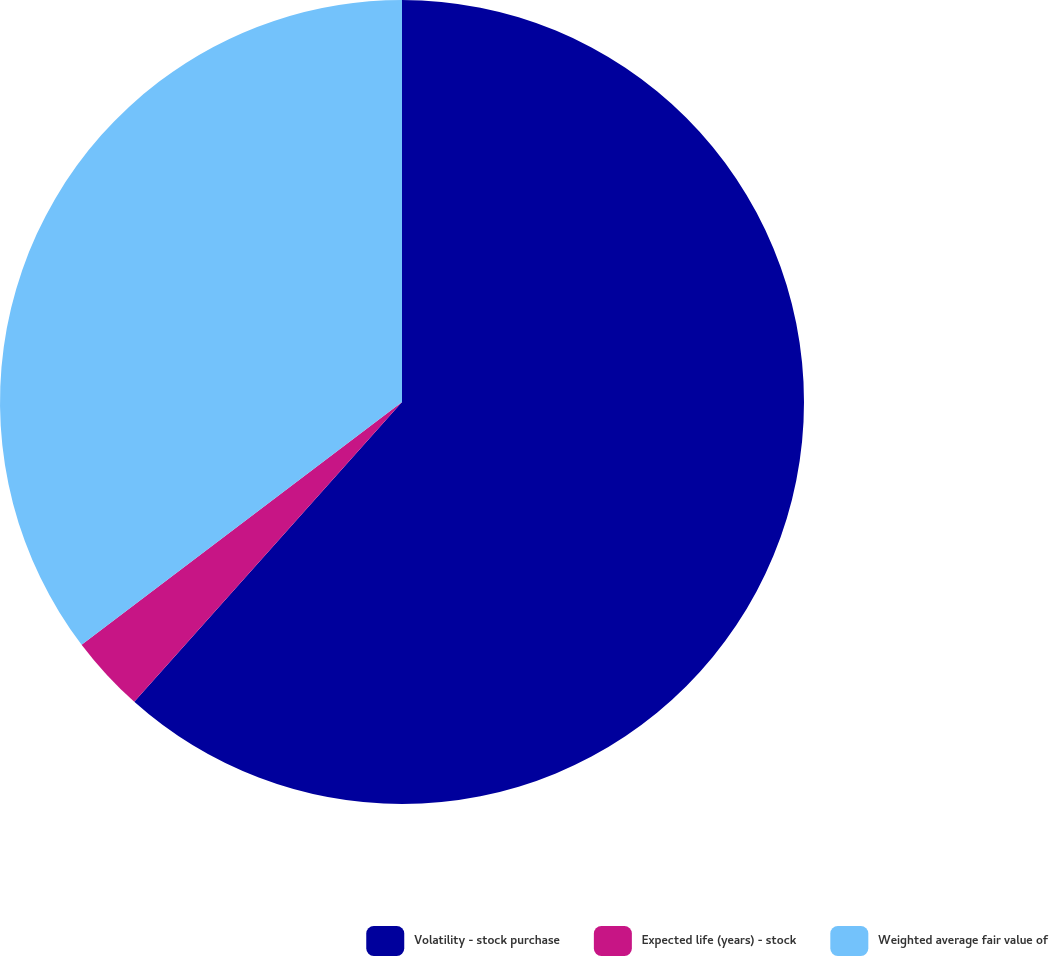Convert chart. <chart><loc_0><loc_0><loc_500><loc_500><pie_chart><fcel>Volatility - stock purchase<fcel>Expected life (years) - stock<fcel>Weighted average fair value of<nl><fcel>61.6%<fcel>3.08%<fcel>35.32%<nl></chart> 